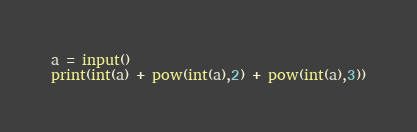<code> <loc_0><loc_0><loc_500><loc_500><_Python_>a = input()
print(int(a) + pow(int(a),2) + pow(int(a),3))</code> 